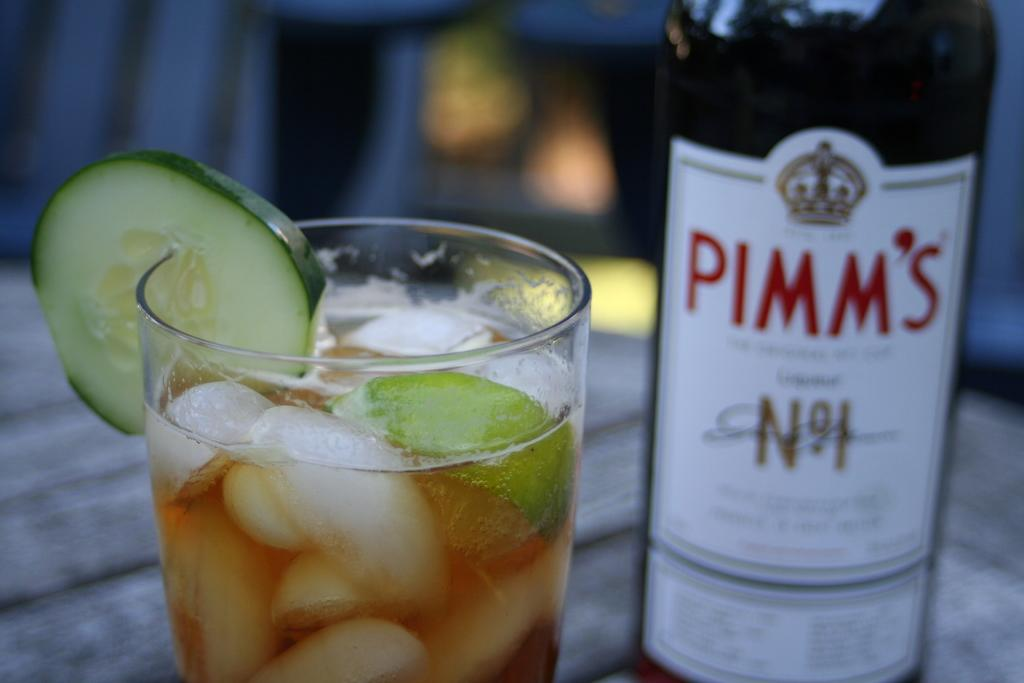<image>
Create a compact narrative representing the image presented. Bottle of PIMM'S next to a cup of alcohol. 